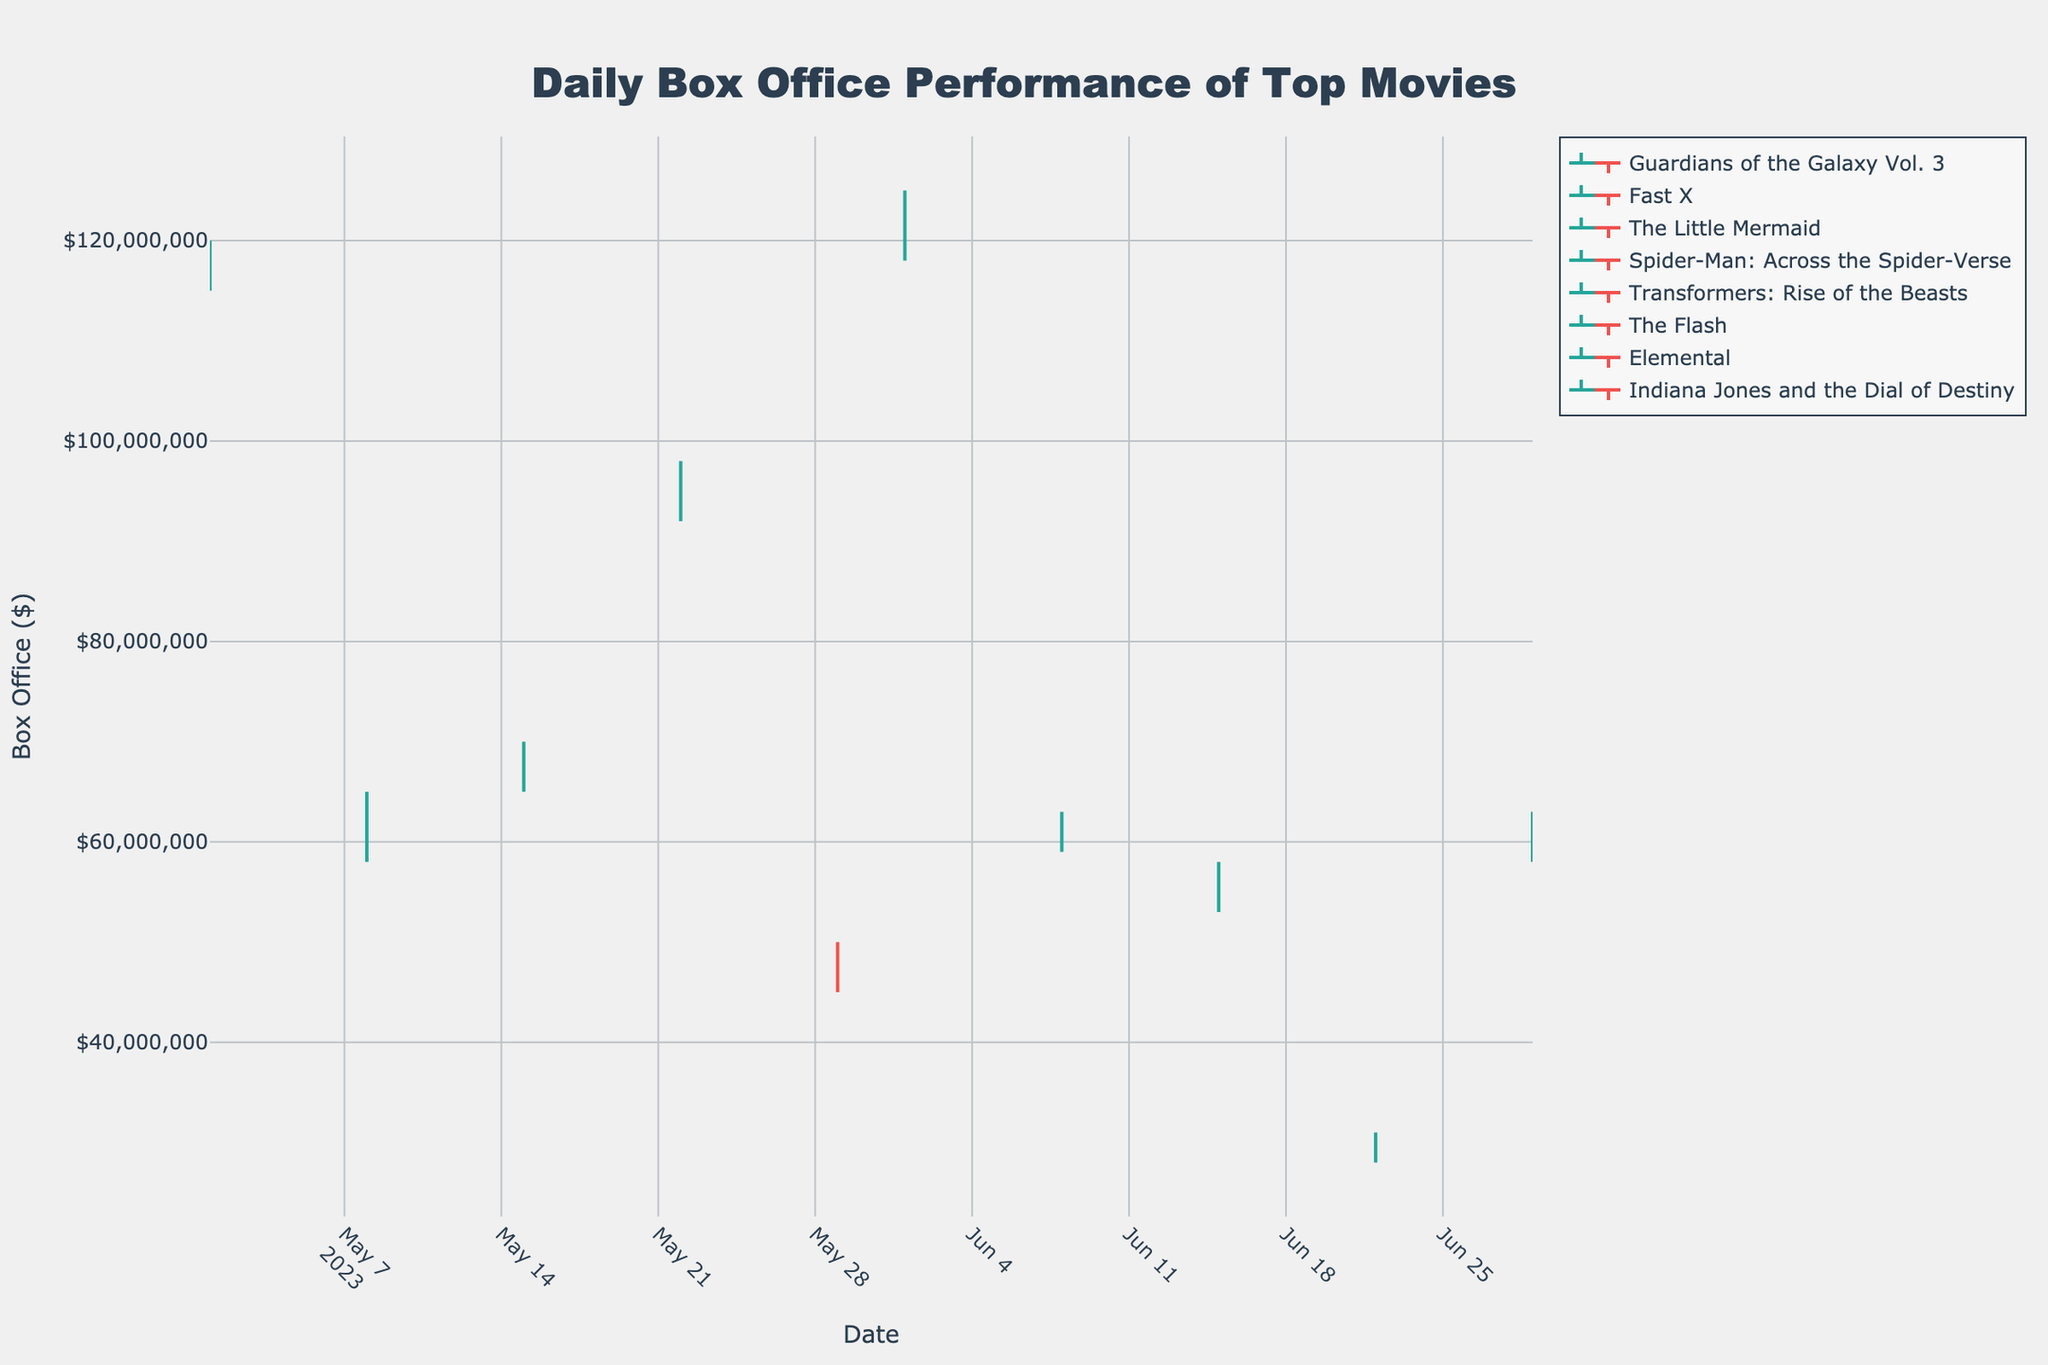What's the title of the chart? The title is prominently displayed at the top of the chart. The text in a larger font signifies the title, which is centered for emphasis.
Answer: Daily Box Office Performance of Top Movies How many movies are represented in the chart? Each OHLC trace represents a different movie. Counting the unique lines in the legend can determine the number of movies.
Answer: 5 What is the highest value (High) for "Spider-Man: Across the Spider-Verse"? Look for the OHLC data for "Spider-Man: Across the Spider-Verse" and identify the highest peak on the chart. The description of the data mentions this highest point.
Answer: 125,000,000 Which movie had the lowest closing value? Compare the "Close" values for all the movies. The lowest value can be identified by scanning the endpoints of the colored bars in the OHLC chart.
Answer: Elemental Between "Guardians of the Galaxy Vol. 3" and "Transformers: Rise of the Beasts", which had higher opening sales on their earliest dates? Compare the "Open" values at the earliest dates (2023-05-01 for "Guardians of the Galaxy Vol. 3" and 2023-06-08 for "Transformers: Rise of the Beasts"). Use the chart to read off the values and see which open value is higher.
Answer: Guardians of the Galaxy Vol. 3 How did the opening and closing values of "The Little Mermaid" change from May 22 to May 29? Note the "Open" and "Close" values on May 22 and May 29 for "The Little Mermaid". Subtract the May 29 values from the May 22 values to observe the change.
Answer: Open decreased by 47,000,000, Close decreased by 49,000,000 Which two movies had the closest high ticket sales? Compare the "High" values for all movies and determine the two values that are nearest to each other. This involves inspecting the peaks of the OHLC lines for proximity.
Answer: Guardians of the Galaxy Vol. 3 and Spider-Man: Across the Spider-Verse What's the average closing value of all movies portrayed in the chart? Summing all the "Close" values from each OHLC line, then dividing by the number of movies provided will give the average closing value. The data contains the closing values.
Answer: 72,500,000 Which movie had a decreasing trend throughout its entire span on the chart? Analyze the "Open" and "Close" values from the start to end. A decreasing trend means the "Close" values are consistently lower than the "Open" values. Use the OHLC lines to spot this downward pattern.
Answer: Elemental 